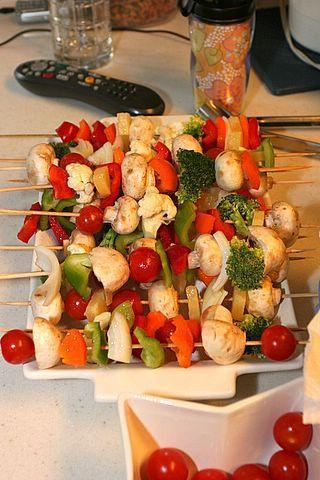How many dining tables are there?
Give a very brief answer. 2. How many people are wearing jeans?
Give a very brief answer. 0. 